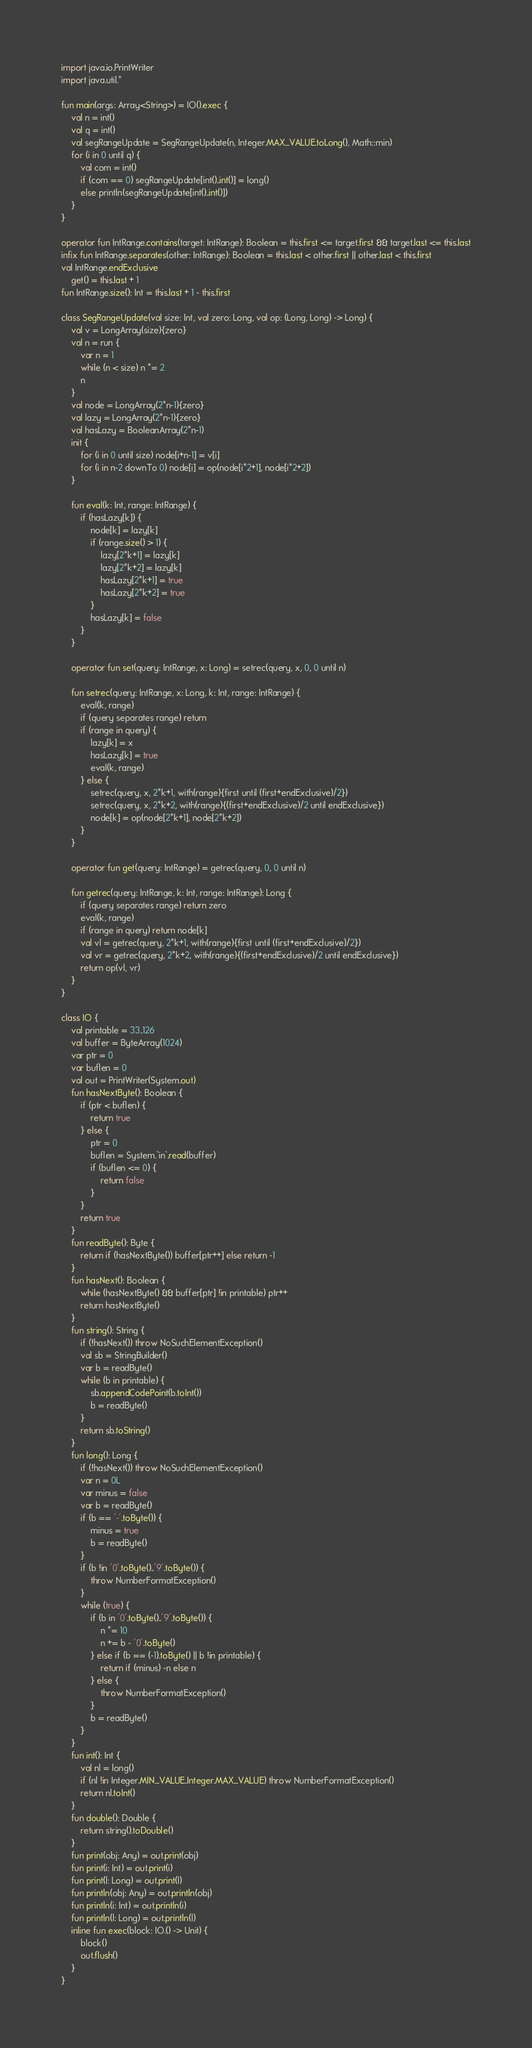<code> <loc_0><loc_0><loc_500><loc_500><_Kotlin_>import java.io.PrintWriter
import java.util.*

fun main(args: Array<String>) = IO().exec {
    val n = int()
    val q = int()
    val segRangeUpdate = SegRangeUpdate(n, Integer.MAX_VALUE.toLong(), Math::min)
    for (i in 0 until q) {
        val com = int()
        if (com == 0) segRangeUpdate[int()..int()] = long()
        else println(segRangeUpdate[int()..int()])
    }
}

operator fun IntRange.contains(target: IntRange): Boolean = this.first <= target.first && target.last <= this.last
infix fun IntRange.separates(other: IntRange): Boolean = this.last < other.first || other.last < this.first
val IntRange.endExclusive
    get() = this.last + 1
fun IntRange.size(): Int = this.last + 1 - this.first

class SegRangeUpdate(val size: Int, val zero: Long, val op: (Long, Long) -> Long) {
    val v = LongArray(size){zero}
    val n = run {
        var n = 1
        while (n < size) n *= 2
        n
    }
    val node = LongArray(2*n-1){zero}
    val lazy = LongArray(2*n-1){zero}
    val hasLazy = BooleanArray(2*n-1)
    init {
        for (i in 0 until size) node[i+n-1] = v[i]
        for (i in n-2 downTo 0) node[i] = op(node[i*2+1], node[i*2+2])
    }

    fun eval(k: Int, range: IntRange) {
        if (hasLazy[k]) {
            node[k] = lazy[k]
            if (range.size() > 1) {
                lazy[2*k+1] = lazy[k]
                lazy[2*k+2] = lazy[k]
                hasLazy[2*k+1] = true
                hasLazy[2*k+2] = true
            }
            hasLazy[k] = false
        }
    }

    operator fun set(query: IntRange, x: Long) = setrec(query, x, 0, 0 until n)

    fun setrec(query: IntRange, x: Long, k: Int, range: IntRange) {
        eval(k, range)
        if (query separates range) return
        if (range in query) {
            lazy[k] = x
            hasLazy[k] = true
            eval(k, range)
        } else {
            setrec(query, x, 2*k+1, with(range){first until (first+endExclusive)/2})
            setrec(query, x, 2*k+2, with(range){(first+endExclusive)/2 until endExclusive})
            node[k] = op(node[2*k+1], node[2*k+2])
        }
    }

    operator fun get(query: IntRange) = getrec(query, 0, 0 until n)

    fun getrec(query: IntRange, k: Int, range: IntRange): Long {
        if (query separates range) return zero
        eval(k, range)
        if (range in query) return node[k]
        val vl = getrec(query, 2*k+1, with(range){first until (first+endExclusive)/2})
        val vr = getrec(query, 2*k+2, with(range){(first+endExclusive)/2 until endExclusive})
        return op(vl, vr)
    }
}

class IO {
    val printable = 33..126
    val buffer = ByteArray(1024)
    var ptr = 0
    var buflen = 0
    val out = PrintWriter(System.out)
    fun hasNextByte(): Boolean {
        if (ptr < buflen) {
            return true
        } else {
            ptr = 0
            buflen = System.`in`.read(buffer)
            if (buflen <= 0) {
                return false
            }
        }
        return true
    }
    fun readByte(): Byte {
        return if (hasNextByte()) buffer[ptr++] else return -1
    }
    fun hasNext(): Boolean {
        while (hasNextByte() && buffer[ptr] !in printable) ptr++
        return hasNextByte()
    }
    fun string(): String {
        if (!hasNext()) throw NoSuchElementException()
        val sb = StringBuilder()
        var b = readByte()
        while (b in printable) {
            sb.appendCodePoint(b.toInt())
            b = readByte()
        }
        return sb.toString()
    }
    fun long(): Long {
        if (!hasNext()) throw NoSuchElementException()
        var n = 0L
        var minus = false
        var b = readByte()
        if (b == '-'.toByte()) {
            minus = true
            b = readByte()
        }
        if (b !in '0'.toByte()..'9'.toByte()) {
            throw NumberFormatException()
        }
        while (true) {
            if (b in '0'.toByte()..'9'.toByte()) {
                n *= 10
                n += b - '0'.toByte()
            } else if (b == (-1).toByte() || b !in printable) {
                return if (minus) -n else n
            } else {
                throw NumberFormatException()
            }
            b = readByte()
        }
    }
    fun int(): Int {
        val nl = long()
        if (nl !in Integer.MIN_VALUE..Integer.MAX_VALUE) throw NumberFormatException()
        return nl.toInt()
    }
    fun double(): Double {
        return string().toDouble()
    }
    fun print(obj: Any) = out.print(obj)
    fun print(i: Int) = out.print(i)
    fun print(l: Long) = out.print(l)
    fun println(obj: Any) = out.println(obj)
    fun println(i: Int) = out.println(i)
    fun println(l: Long) = out.println(l)
    inline fun exec(block: IO.() -> Unit) {
        block()
        out.flush()
    }
}
</code> 